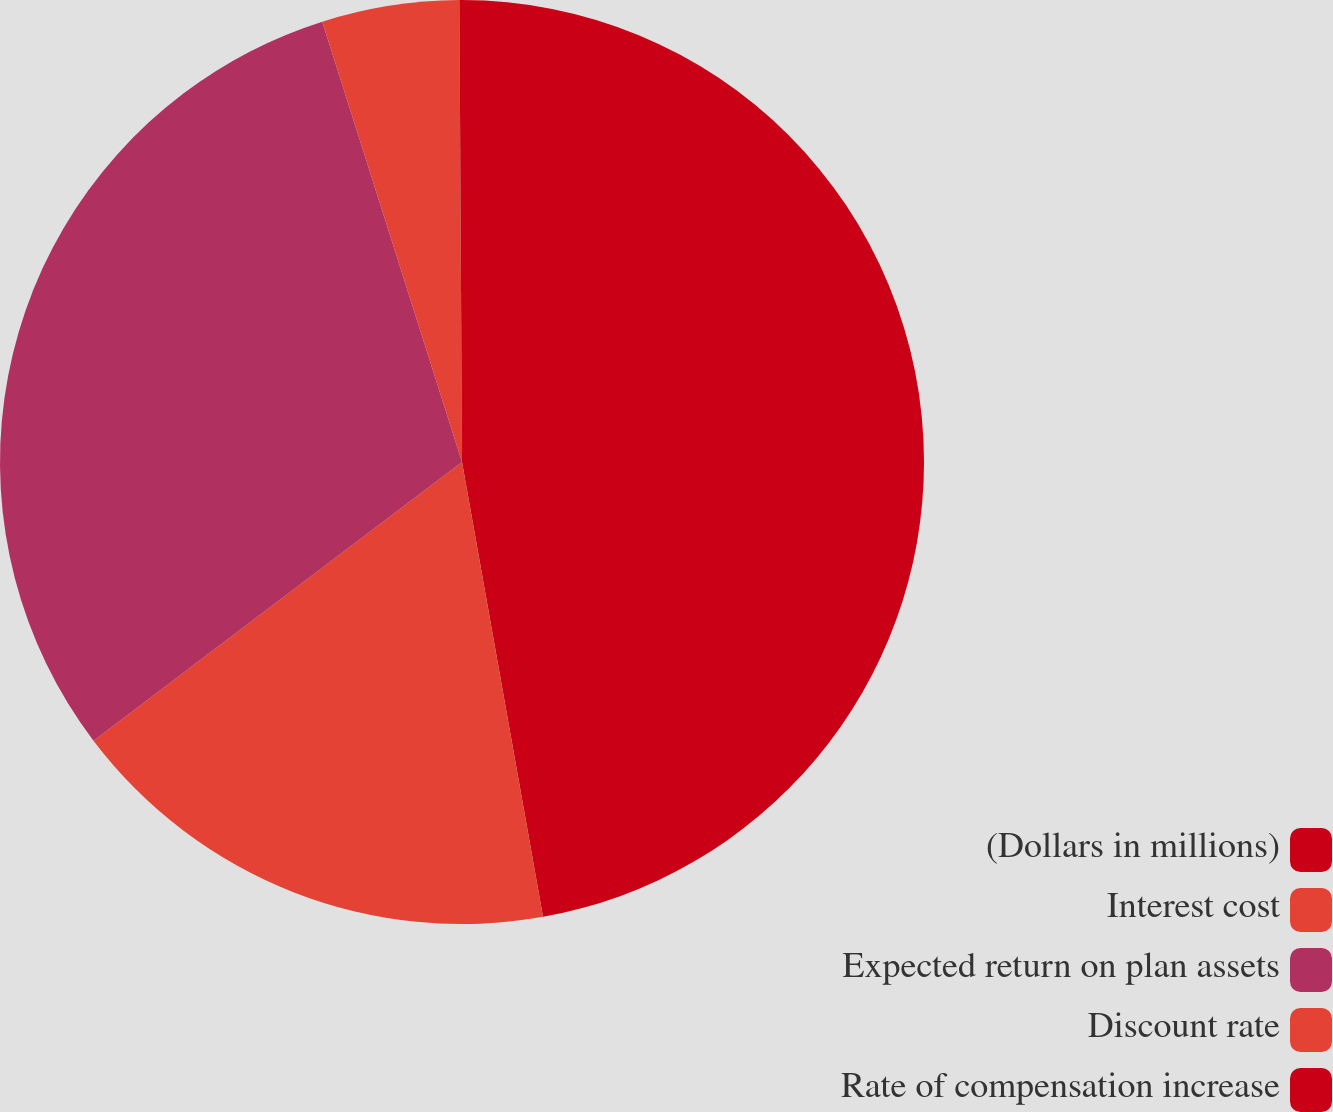<chart> <loc_0><loc_0><loc_500><loc_500><pie_chart><fcel>(Dollars in millions)<fcel>Interest cost<fcel>Expected return on plan assets<fcel>Discount rate<fcel>Rate of compensation increase<nl><fcel>47.19%<fcel>17.5%<fcel>30.41%<fcel>4.8%<fcel>0.09%<nl></chart> 